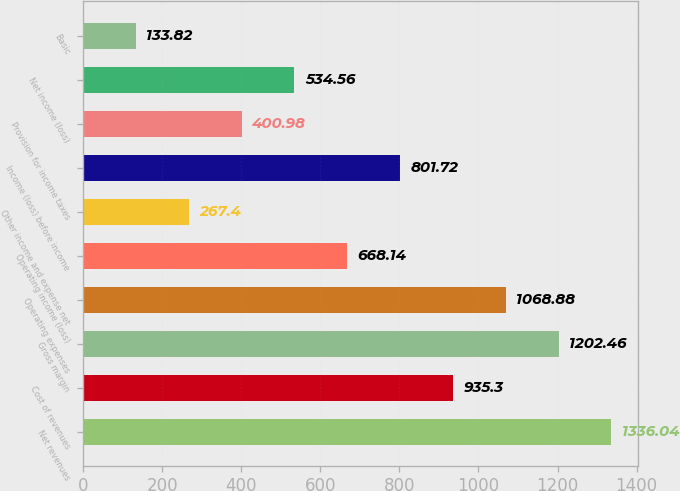Convert chart to OTSL. <chart><loc_0><loc_0><loc_500><loc_500><bar_chart><fcel>Net revenues<fcel>Cost of revenues<fcel>Gross margin<fcel>Operating expenses<fcel>Operating income (loss)<fcel>Other income and expense net<fcel>Income (loss) before income<fcel>Provision for income taxes<fcel>Net income (loss)<fcel>Basic<nl><fcel>1336.04<fcel>935.3<fcel>1202.46<fcel>1068.88<fcel>668.14<fcel>267.4<fcel>801.72<fcel>400.98<fcel>534.56<fcel>133.82<nl></chart> 